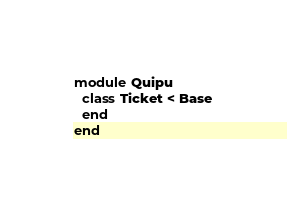<code> <loc_0><loc_0><loc_500><loc_500><_Ruby_>module Quipu
  class Ticket < Base
  end
end
</code> 